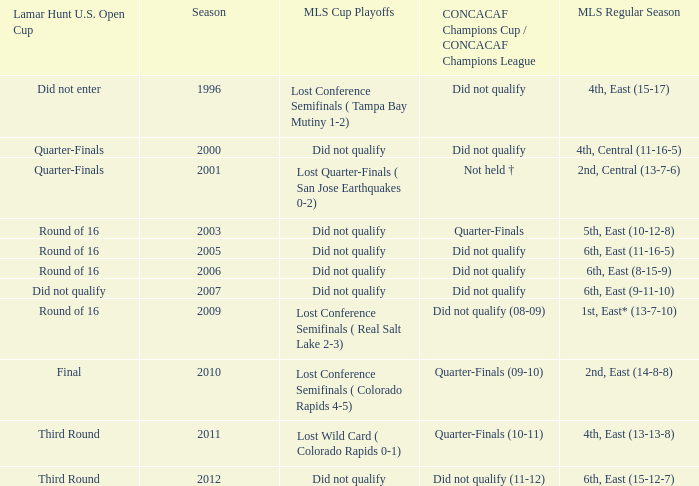What was the season when mls regular season was 6th, east (9-11-10)? 2007.0. 